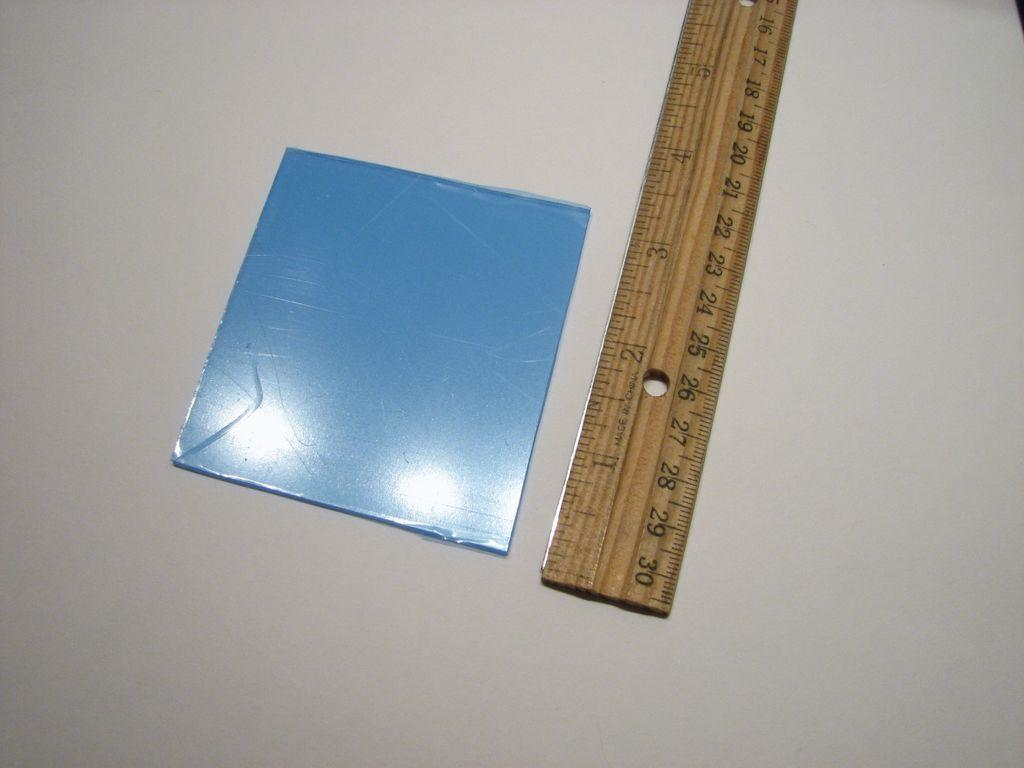<image>
Create a compact narrative representing the image presented. A ruler measures an object that is about 3 inches. 